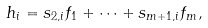Convert formula to latex. <formula><loc_0><loc_0><loc_500><loc_500>h _ { i } = s _ { 2 , i } f _ { 1 } + \cdots + s _ { m + 1 , i } f _ { m } ,</formula> 